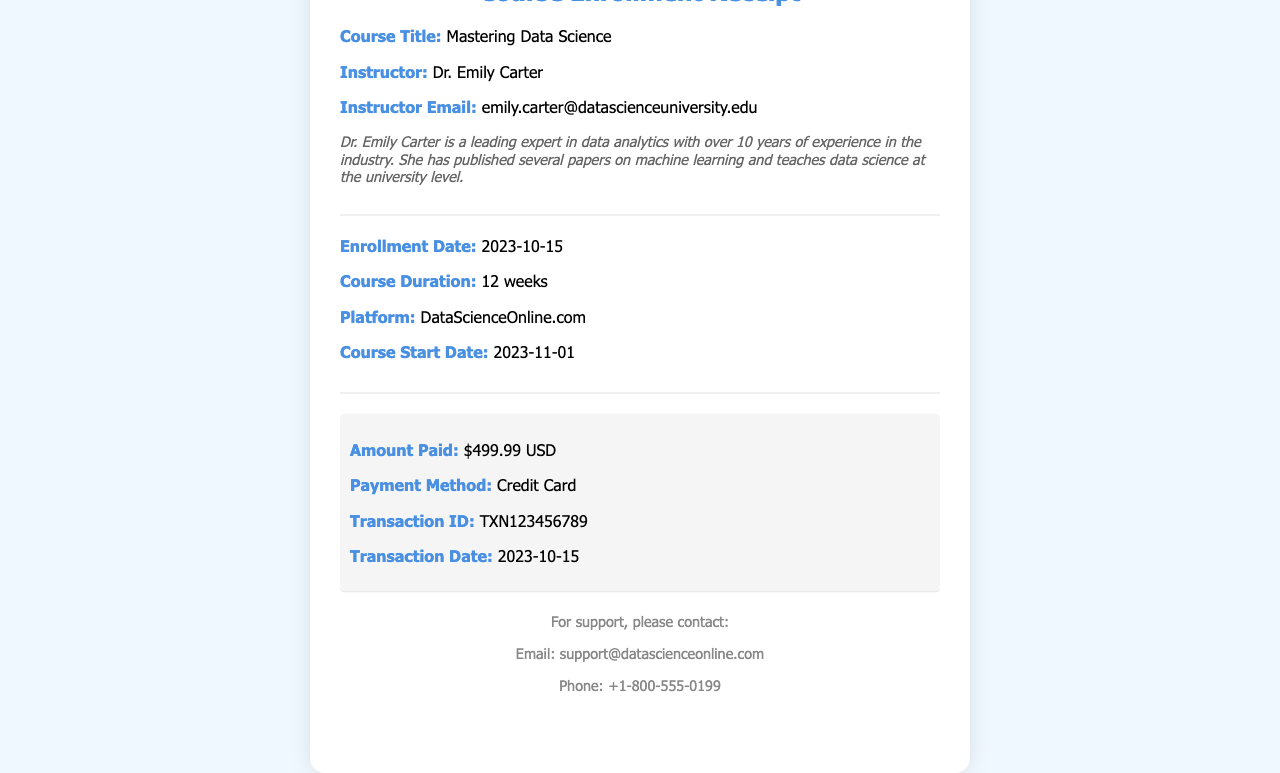what is the course title? The course title is specified clearly in the document in the section detailing course information.
Answer: Mastering Data Science who is the instructor? The instructor's name is provided in the receipt under the course details section.
Answer: Dr. Emily Carter what is the payment amount? The payment amount is outlined specifically in the payment details section of the document.
Answer: $499.99 USD when does the course start? The course start date is indicated in the section that lists the course details and timelines.
Answer: 2023-11-01 what is the transaction ID? The transaction ID is explicitly mentioned in the payment details of the receipt.
Answer: TXN123456789 how long is the course duration? The course duration is specified as part of the course information outlined in the document.
Answer: 12 weeks when was the enrollment date? The enrollment date appears in the section regarding the course details.
Answer: 2023-10-15 which platform is the course offered on? The platform where the course is hosted is mentioned in the related section.
Answer: DataScienceOnline.com what contact email is provided for support? The support contact email is situated in the last section dedicated to contact information.
Answer: support@datascienceonline.com 